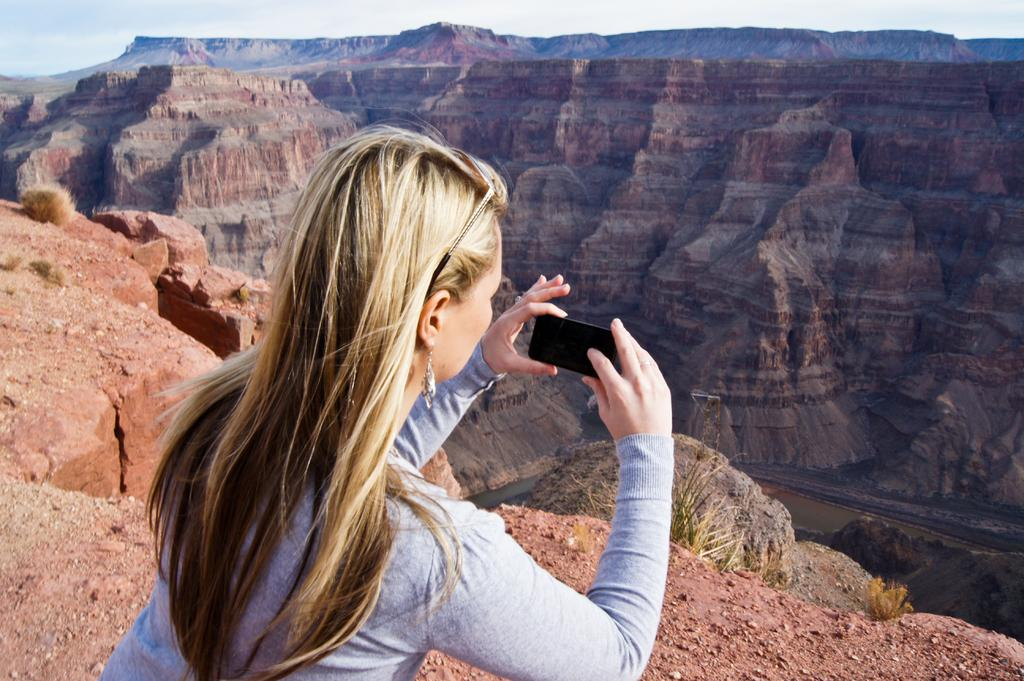Who is the main subject in the image? There is a woman in the image. What is the woman holding in the image? The woman is holding a mobile phone. What type of landscape can be seen in the image? There are mountains visible in the image. What type of magic trick is the woman performing with the toy in the image? There is no toy or magic trick present in the image; the woman is simply holding a mobile phone. 